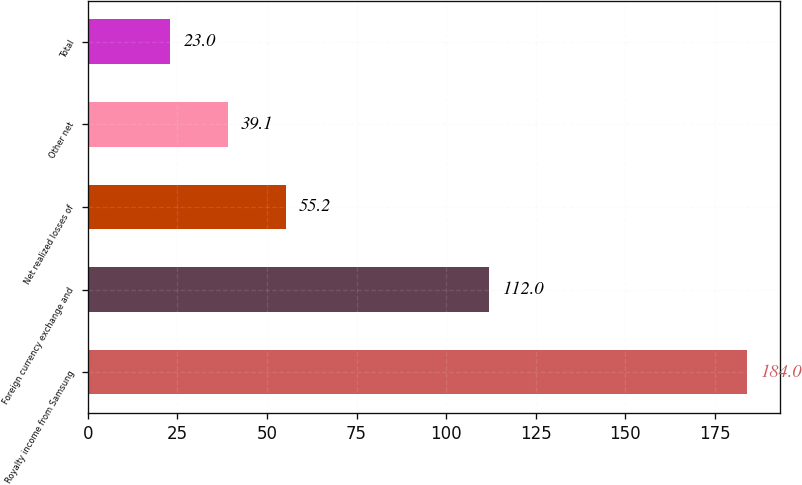Convert chart to OTSL. <chart><loc_0><loc_0><loc_500><loc_500><bar_chart><fcel>Royalty income from Samsung<fcel>Foreign currency exchange and<fcel>Net realized losses of<fcel>Other net<fcel>Total<nl><fcel>184<fcel>112<fcel>55.2<fcel>39.1<fcel>23<nl></chart> 